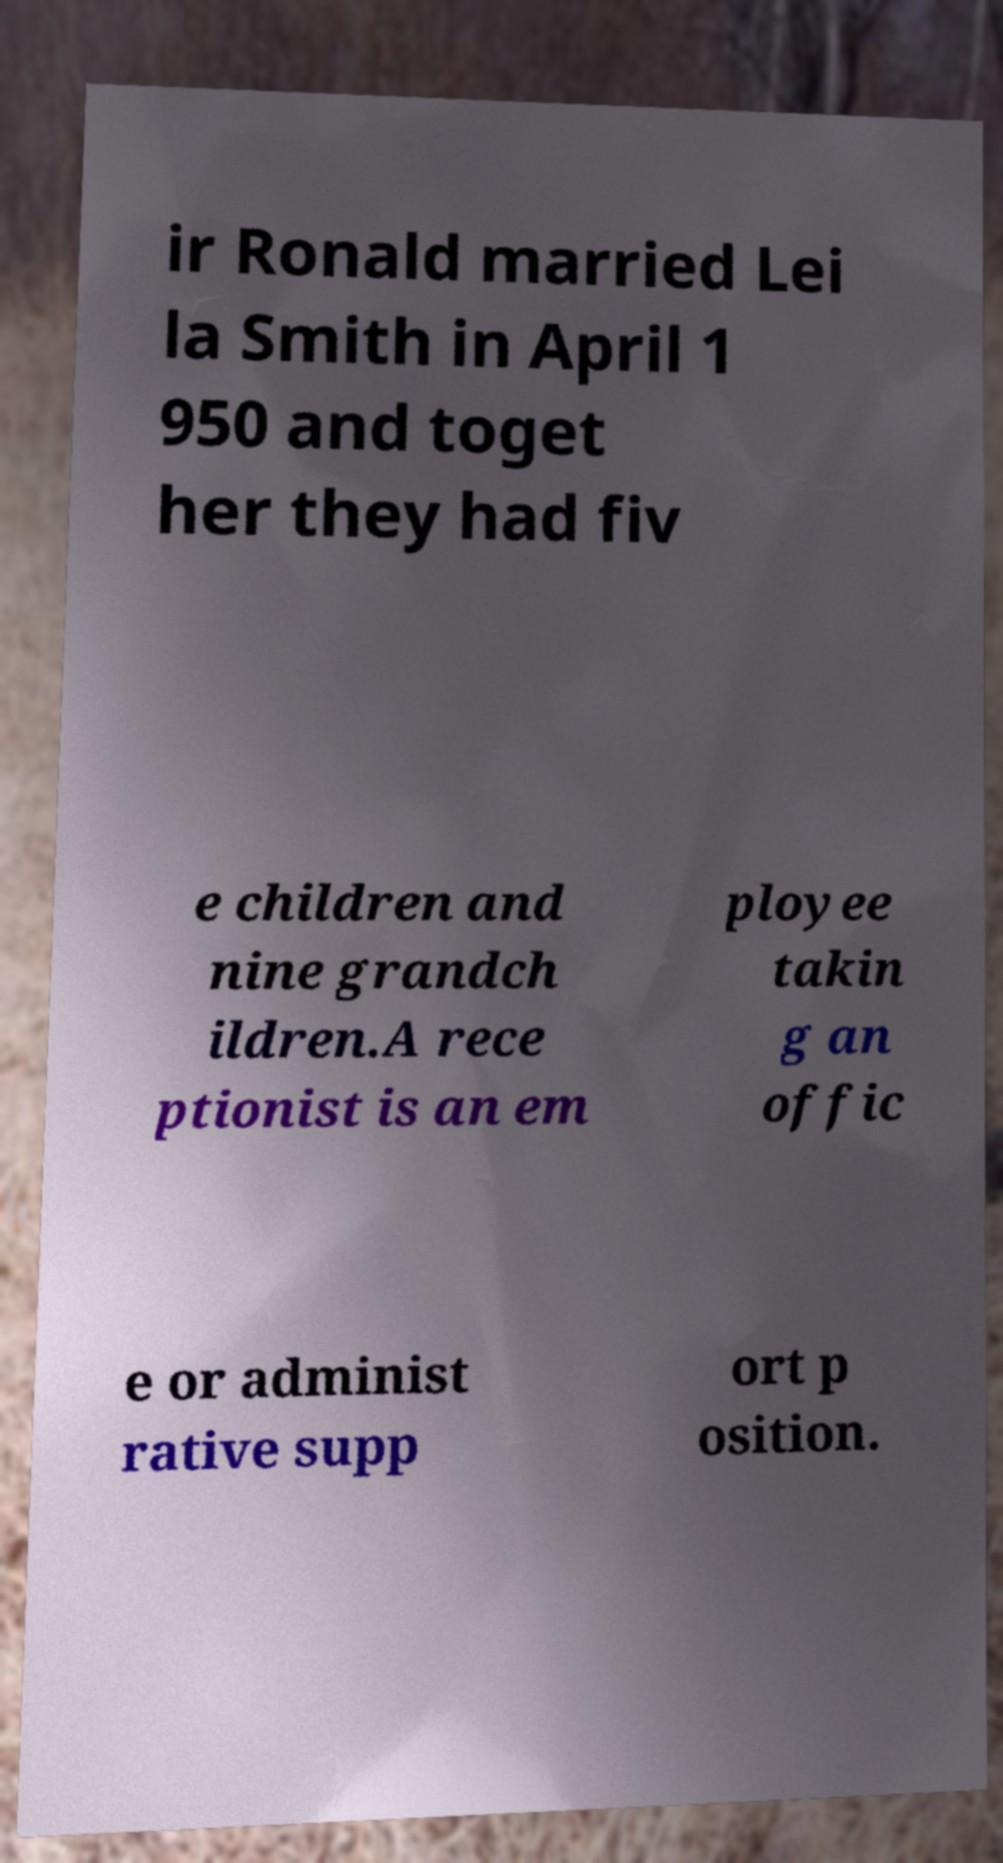I need the written content from this picture converted into text. Can you do that? ir Ronald married Lei la Smith in April 1 950 and toget her they had fiv e children and nine grandch ildren.A rece ptionist is an em ployee takin g an offic e or administ rative supp ort p osition. 